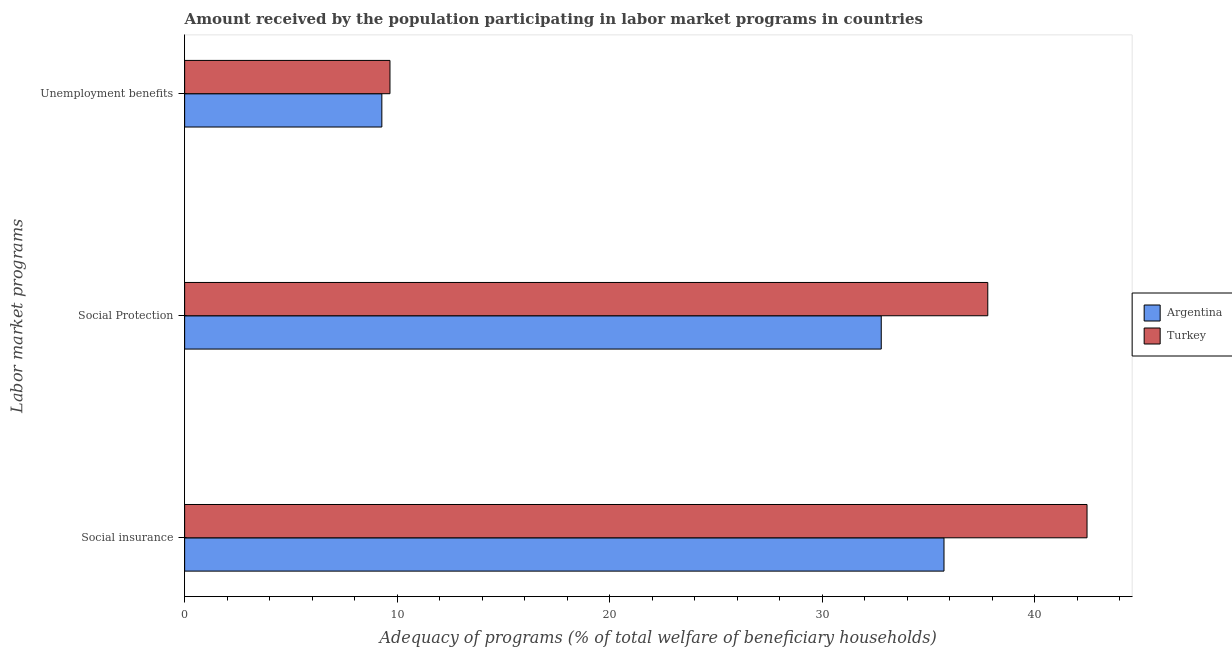How many different coloured bars are there?
Your answer should be very brief. 2. How many bars are there on the 1st tick from the top?
Offer a very short reply. 2. How many bars are there on the 2nd tick from the bottom?
Provide a succinct answer. 2. What is the label of the 2nd group of bars from the top?
Ensure brevity in your answer.  Social Protection. What is the amount received by the population participating in social protection programs in Turkey?
Your answer should be very brief. 37.8. Across all countries, what is the maximum amount received by the population participating in unemployment benefits programs?
Your response must be concise. 9.66. Across all countries, what is the minimum amount received by the population participating in unemployment benefits programs?
Provide a short and direct response. 9.28. What is the total amount received by the population participating in social insurance programs in the graph?
Give a very brief answer. 78.21. What is the difference between the amount received by the population participating in social insurance programs in Turkey and that in Argentina?
Your answer should be very brief. 6.73. What is the difference between the amount received by the population participating in unemployment benefits programs in Turkey and the amount received by the population participating in social insurance programs in Argentina?
Provide a short and direct response. -26.08. What is the average amount received by the population participating in social insurance programs per country?
Offer a terse response. 39.11. What is the difference between the amount received by the population participating in social insurance programs and amount received by the population participating in unemployment benefits programs in Turkey?
Your response must be concise. 32.81. What is the ratio of the amount received by the population participating in social protection programs in Turkey to that in Argentina?
Your response must be concise. 1.15. Is the amount received by the population participating in social protection programs in Argentina less than that in Turkey?
Your answer should be very brief. Yes. Is the difference between the amount received by the population participating in unemployment benefits programs in Argentina and Turkey greater than the difference between the amount received by the population participating in social insurance programs in Argentina and Turkey?
Provide a succinct answer. Yes. What is the difference between the highest and the second highest amount received by the population participating in unemployment benefits programs?
Provide a short and direct response. 0.38. What is the difference between the highest and the lowest amount received by the population participating in social protection programs?
Give a very brief answer. 5.01. In how many countries, is the amount received by the population participating in social insurance programs greater than the average amount received by the population participating in social insurance programs taken over all countries?
Offer a very short reply. 1. Is the sum of the amount received by the population participating in unemployment benefits programs in Turkey and Argentina greater than the maximum amount received by the population participating in social protection programs across all countries?
Provide a succinct answer. No. What does the 1st bar from the bottom in Social insurance represents?
Offer a terse response. Argentina. How many bars are there?
Offer a terse response. 6. Are all the bars in the graph horizontal?
Ensure brevity in your answer.  Yes. How many countries are there in the graph?
Make the answer very short. 2. Are the values on the major ticks of X-axis written in scientific E-notation?
Keep it short and to the point. No. Does the graph contain any zero values?
Your answer should be compact. No. Where does the legend appear in the graph?
Keep it short and to the point. Center right. How are the legend labels stacked?
Provide a succinct answer. Vertical. What is the title of the graph?
Your response must be concise. Amount received by the population participating in labor market programs in countries. What is the label or title of the X-axis?
Offer a terse response. Adequacy of programs (% of total welfare of beneficiary households). What is the label or title of the Y-axis?
Make the answer very short. Labor market programs. What is the Adequacy of programs (% of total welfare of beneficiary households) in Argentina in Social insurance?
Your response must be concise. 35.74. What is the Adequacy of programs (% of total welfare of beneficiary households) of Turkey in Social insurance?
Provide a short and direct response. 42.47. What is the Adequacy of programs (% of total welfare of beneficiary households) in Argentina in Social Protection?
Provide a succinct answer. 32.79. What is the Adequacy of programs (% of total welfare of beneficiary households) in Turkey in Social Protection?
Offer a very short reply. 37.8. What is the Adequacy of programs (% of total welfare of beneficiary households) of Argentina in Unemployment benefits?
Give a very brief answer. 9.28. What is the Adequacy of programs (% of total welfare of beneficiary households) in Turkey in Unemployment benefits?
Make the answer very short. 9.66. Across all Labor market programs, what is the maximum Adequacy of programs (% of total welfare of beneficiary households) in Argentina?
Keep it short and to the point. 35.74. Across all Labor market programs, what is the maximum Adequacy of programs (% of total welfare of beneficiary households) of Turkey?
Offer a terse response. 42.47. Across all Labor market programs, what is the minimum Adequacy of programs (% of total welfare of beneficiary households) of Argentina?
Provide a succinct answer. 9.28. Across all Labor market programs, what is the minimum Adequacy of programs (% of total welfare of beneficiary households) in Turkey?
Provide a short and direct response. 9.66. What is the total Adequacy of programs (% of total welfare of beneficiary households) of Argentina in the graph?
Provide a succinct answer. 77.81. What is the total Adequacy of programs (% of total welfare of beneficiary households) of Turkey in the graph?
Make the answer very short. 89.93. What is the difference between the Adequacy of programs (% of total welfare of beneficiary households) in Argentina in Social insurance and that in Social Protection?
Your response must be concise. 2.95. What is the difference between the Adequacy of programs (% of total welfare of beneficiary households) in Turkey in Social insurance and that in Social Protection?
Your answer should be very brief. 4.67. What is the difference between the Adequacy of programs (% of total welfare of beneficiary households) in Argentina in Social insurance and that in Unemployment benefits?
Your answer should be very brief. 26.46. What is the difference between the Adequacy of programs (% of total welfare of beneficiary households) of Turkey in Social insurance and that in Unemployment benefits?
Provide a short and direct response. 32.81. What is the difference between the Adequacy of programs (% of total welfare of beneficiary households) in Argentina in Social Protection and that in Unemployment benefits?
Ensure brevity in your answer.  23.5. What is the difference between the Adequacy of programs (% of total welfare of beneficiary households) of Turkey in Social Protection and that in Unemployment benefits?
Make the answer very short. 28.14. What is the difference between the Adequacy of programs (% of total welfare of beneficiary households) in Argentina in Social insurance and the Adequacy of programs (% of total welfare of beneficiary households) in Turkey in Social Protection?
Provide a succinct answer. -2.06. What is the difference between the Adequacy of programs (% of total welfare of beneficiary households) of Argentina in Social insurance and the Adequacy of programs (% of total welfare of beneficiary households) of Turkey in Unemployment benefits?
Your answer should be compact. 26.08. What is the difference between the Adequacy of programs (% of total welfare of beneficiary households) of Argentina in Social Protection and the Adequacy of programs (% of total welfare of beneficiary households) of Turkey in Unemployment benefits?
Your answer should be very brief. 23.12. What is the average Adequacy of programs (% of total welfare of beneficiary households) of Argentina per Labor market programs?
Your answer should be compact. 25.94. What is the average Adequacy of programs (% of total welfare of beneficiary households) of Turkey per Labor market programs?
Offer a very short reply. 29.98. What is the difference between the Adequacy of programs (% of total welfare of beneficiary households) of Argentina and Adequacy of programs (% of total welfare of beneficiary households) of Turkey in Social insurance?
Ensure brevity in your answer.  -6.73. What is the difference between the Adequacy of programs (% of total welfare of beneficiary households) of Argentina and Adequacy of programs (% of total welfare of beneficiary households) of Turkey in Social Protection?
Your answer should be very brief. -5.01. What is the difference between the Adequacy of programs (% of total welfare of beneficiary households) of Argentina and Adequacy of programs (% of total welfare of beneficiary households) of Turkey in Unemployment benefits?
Your answer should be compact. -0.38. What is the ratio of the Adequacy of programs (% of total welfare of beneficiary households) in Argentina in Social insurance to that in Social Protection?
Your answer should be compact. 1.09. What is the ratio of the Adequacy of programs (% of total welfare of beneficiary households) of Turkey in Social insurance to that in Social Protection?
Make the answer very short. 1.12. What is the ratio of the Adequacy of programs (% of total welfare of beneficiary households) in Argentina in Social insurance to that in Unemployment benefits?
Make the answer very short. 3.85. What is the ratio of the Adequacy of programs (% of total welfare of beneficiary households) of Turkey in Social insurance to that in Unemployment benefits?
Offer a very short reply. 4.39. What is the ratio of the Adequacy of programs (% of total welfare of beneficiary households) in Argentina in Social Protection to that in Unemployment benefits?
Keep it short and to the point. 3.53. What is the ratio of the Adequacy of programs (% of total welfare of beneficiary households) of Turkey in Social Protection to that in Unemployment benefits?
Offer a terse response. 3.91. What is the difference between the highest and the second highest Adequacy of programs (% of total welfare of beneficiary households) in Argentina?
Your response must be concise. 2.95. What is the difference between the highest and the second highest Adequacy of programs (% of total welfare of beneficiary households) in Turkey?
Make the answer very short. 4.67. What is the difference between the highest and the lowest Adequacy of programs (% of total welfare of beneficiary households) of Argentina?
Provide a succinct answer. 26.46. What is the difference between the highest and the lowest Adequacy of programs (% of total welfare of beneficiary households) in Turkey?
Offer a very short reply. 32.81. 